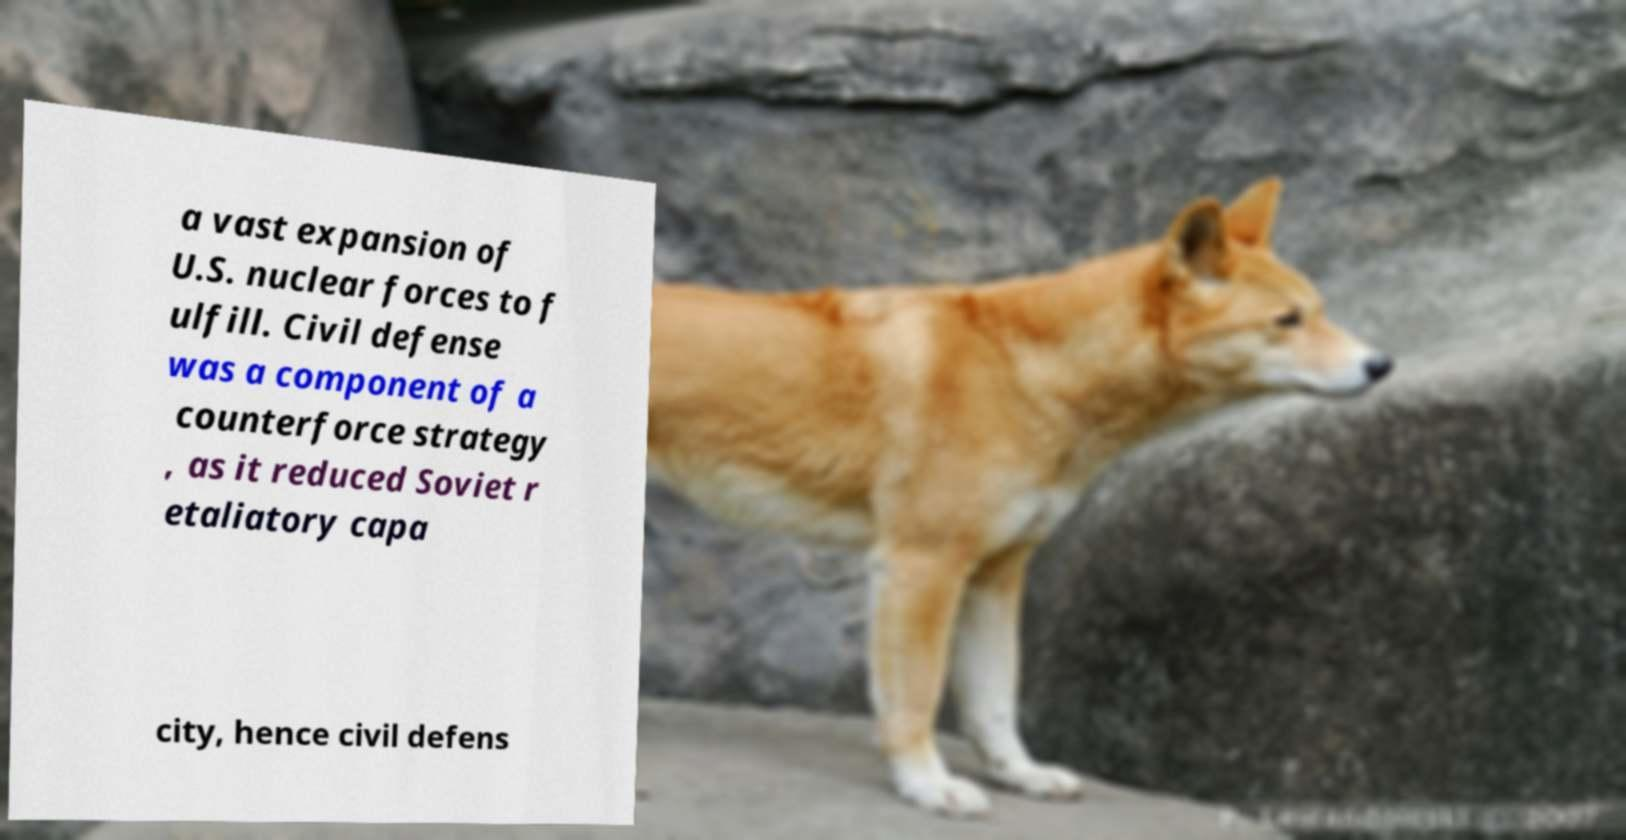I need the written content from this picture converted into text. Can you do that? a vast expansion of U.S. nuclear forces to f ulfill. Civil defense was a component of a counterforce strategy , as it reduced Soviet r etaliatory capa city, hence civil defens 